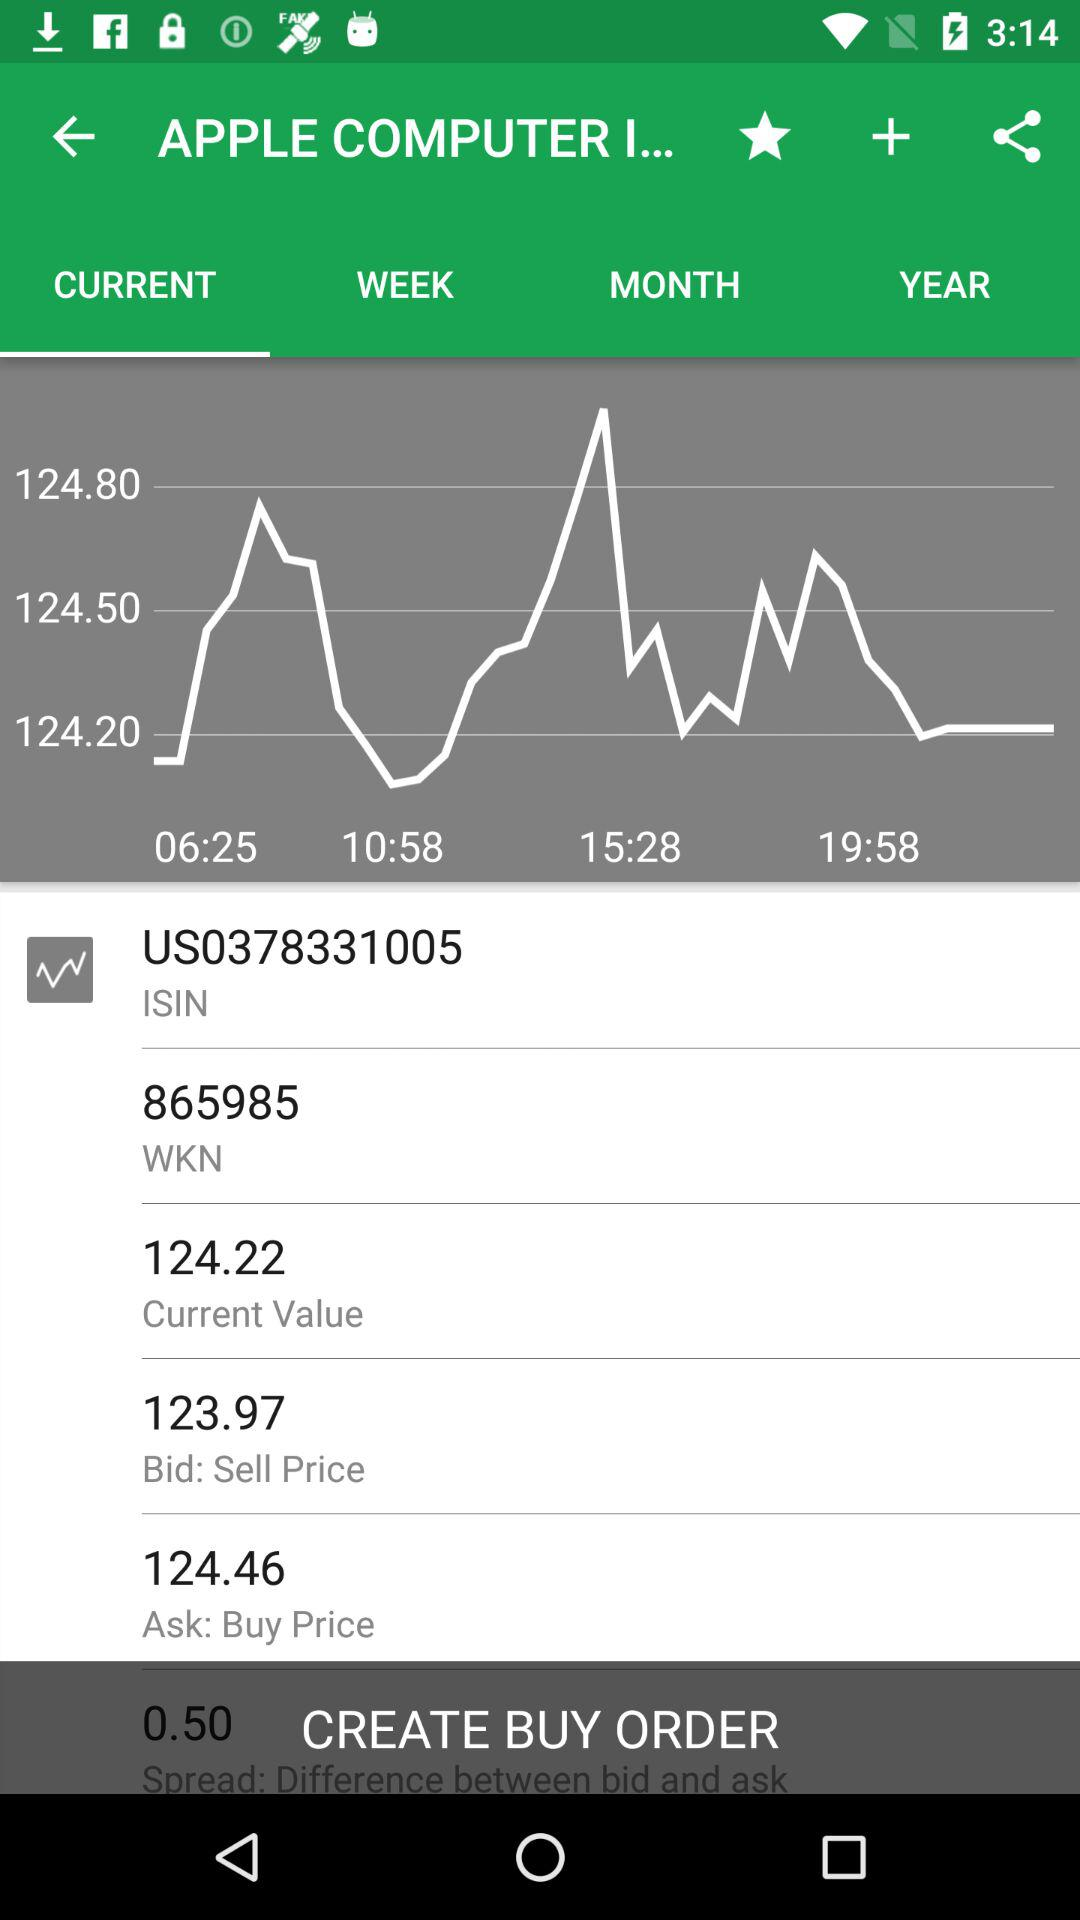What's the selling price? The selling price is 123.97. 